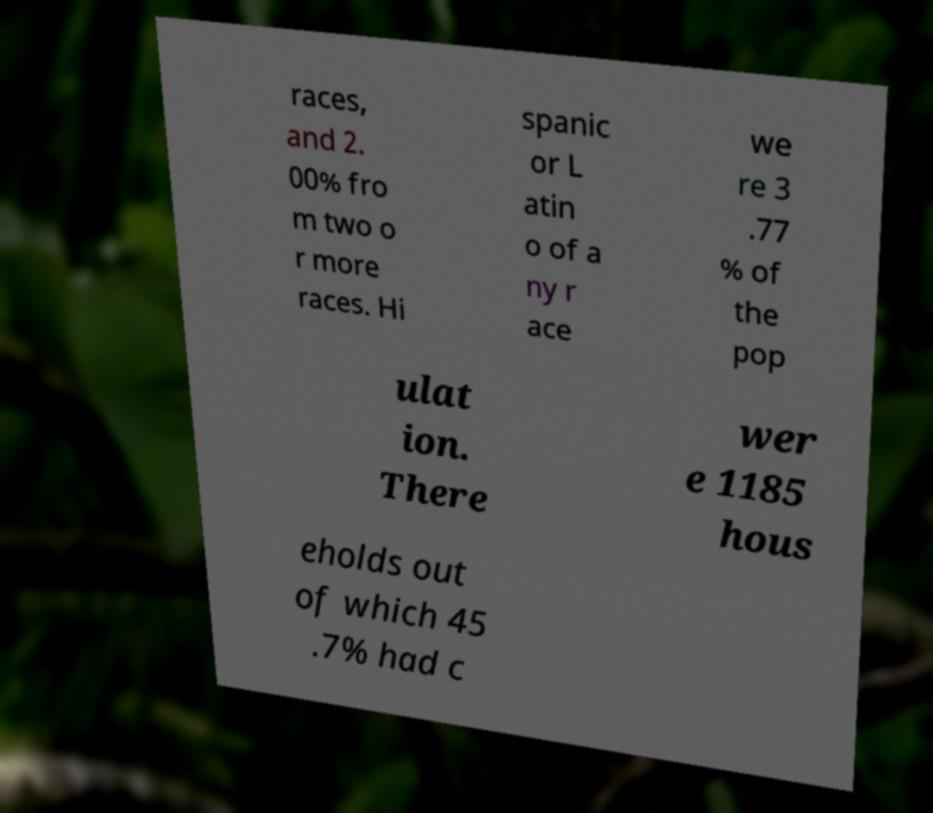Please read and relay the text visible in this image. What does it say? races, and 2. 00% fro m two o r more races. Hi spanic or L atin o of a ny r ace we re 3 .77 % of the pop ulat ion. There wer e 1185 hous eholds out of which 45 .7% had c 